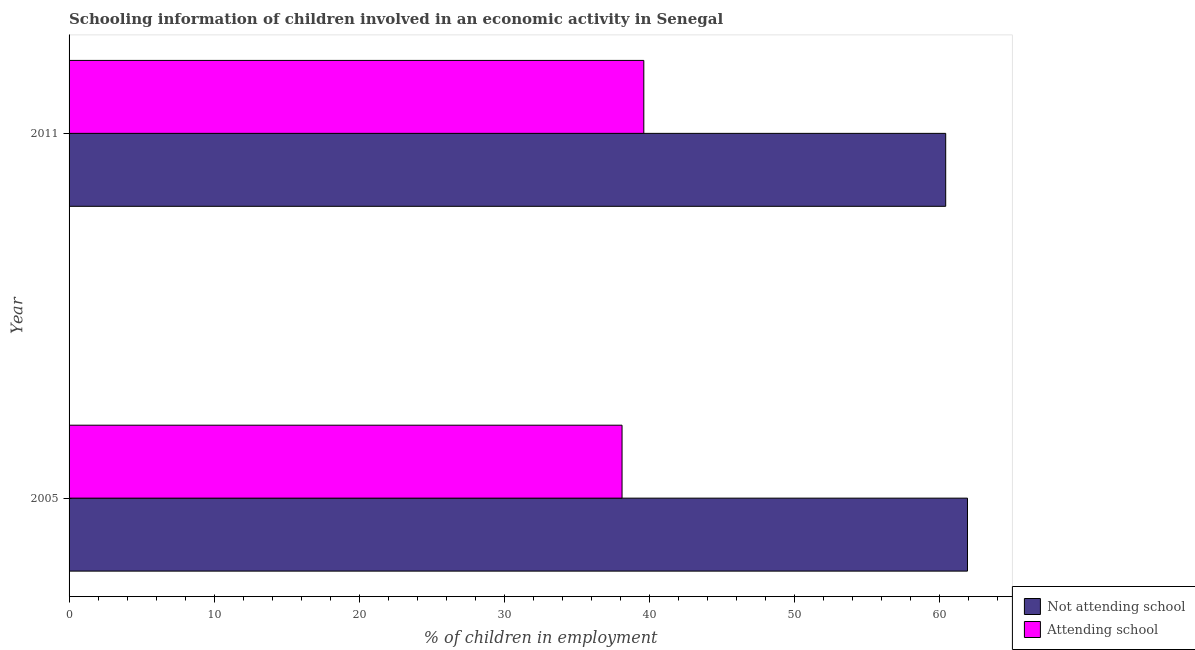How many bars are there on the 1st tick from the top?
Your answer should be very brief. 2. What is the percentage of employed children who are not attending school in 2005?
Make the answer very short. 61.9. Across all years, what is the maximum percentage of employed children who are attending school?
Keep it short and to the point. 39.6. Across all years, what is the minimum percentage of employed children who are attending school?
Make the answer very short. 38.1. In which year was the percentage of employed children who are attending school maximum?
Offer a terse response. 2011. In which year was the percentage of employed children who are not attending school minimum?
Give a very brief answer. 2011. What is the total percentage of employed children who are not attending school in the graph?
Your response must be concise. 122.3. What is the difference between the percentage of employed children who are not attending school in 2005 and that in 2011?
Your response must be concise. 1.5. What is the difference between the percentage of employed children who are not attending school in 2005 and the percentage of employed children who are attending school in 2011?
Make the answer very short. 22.3. What is the average percentage of employed children who are attending school per year?
Your response must be concise. 38.85. In the year 2005, what is the difference between the percentage of employed children who are attending school and percentage of employed children who are not attending school?
Offer a very short reply. -23.8. Is the difference between the percentage of employed children who are attending school in 2005 and 2011 greater than the difference between the percentage of employed children who are not attending school in 2005 and 2011?
Your response must be concise. No. In how many years, is the percentage of employed children who are not attending school greater than the average percentage of employed children who are not attending school taken over all years?
Your response must be concise. 1. What does the 1st bar from the top in 2011 represents?
Give a very brief answer. Attending school. What does the 2nd bar from the bottom in 2011 represents?
Offer a terse response. Attending school. Does the graph contain grids?
Provide a succinct answer. No. Where does the legend appear in the graph?
Provide a succinct answer. Bottom right. How are the legend labels stacked?
Your answer should be very brief. Vertical. What is the title of the graph?
Provide a succinct answer. Schooling information of children involved in an economic activity in Senegal. Does "Nitrous oxide" appear as one of the legend labels in the graph?
Make the answer very short. No. What is the label or title of the X-axis?
Provide a short and direct response. % of children in employment. What is the % of children in employment of Not attending school in 2005?
Provide a succinct answer. 61.9. What is the % of children in employment in Attending school in 2005?
Provide a succinct answer. 38.1. What is the % of children in employment of Not attending school in 2011?
Make the answer very short. 60.4. What is the % of children in employment in Attending school in 2011?
Ensure brevity in your answer.  39.6. Across all years, what is the maximum % of children in employment in Not attending school?
Offer a very short reply. 61.9. Across all years, what is the maximum % of children in employment in Attending school?
Keep it short and to the point. 39.6. Across all years, what is the minimum % of children in employment of Not attending school?
Your answer should be compact. 60.4. Across all years, what is the minimum % of children in employment in Attending school?
Provide a short and direct response. 38.1. What is the total % of children in employment of Not attending school in the graph?
Your answer should be compact. 122.3. What is the total % of children in employment in Attending school in the graph?
Make the answer very short. 77.7. What is the difference between the % of children in employment of Not attending school in 2005 and the % of children in employment of Attending school in 2011?
Your answer should be compact. 22.3. What is the average % of children in employment of Not attending school per year?
Ensure brevity in your answer.  61.15. What is the average % of children in employment of Attending school per year?
Provide a short and direct response. 38.85. In the year 2005, what is the difference between the % of children in employment of Not attending school and % of children in employment of Attending school?
Offer a terse response. 23.8. In the year 2011, what is the difference between the % of children in employment of Not attending school and % of children in employment of Attending school?
Provide a succinct answer. 20.8. What is the ratio of the % of children in employment of Not attending school in 2005 to that in 2011?
Give a very brief answer. 1.02. What is the ratio of the % of children in employment of Attending school in 2005 to that in 2011?
Make the answer very short. 0.96. What is the difference between the highest and the second highest % of children in employment in Not attending school?
Provide a short and direct response. 1.5. What is the difference between the highest and the lowest % of children in employment of Not attending school?
Provide a short and direct response. 1.5. What is the difference between the highest and the lowest % of children in employment of Attending school?
Offer a very short reply. 1.5. 